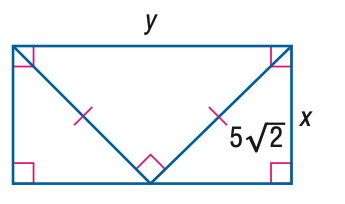Question: Find x.
Choices:
A. \frac { 5 } { 2 } \sqrt { 2 }
B. 5
C. \frac { 5 } { 2 } \sqrt { 6 }
D. 10
Answer with the letter. Answer: B Question: Find y.
Choices:
A. 5
B. 5 \sqrt { 2 }
C. 10
D. 10 \sqrt { 2 }
Answer with the letter. Answer: C 